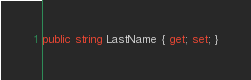<code> <loc_0><loc_0><loc_500><loc_500><_C#_>public string LastName { get; set; }</code> 